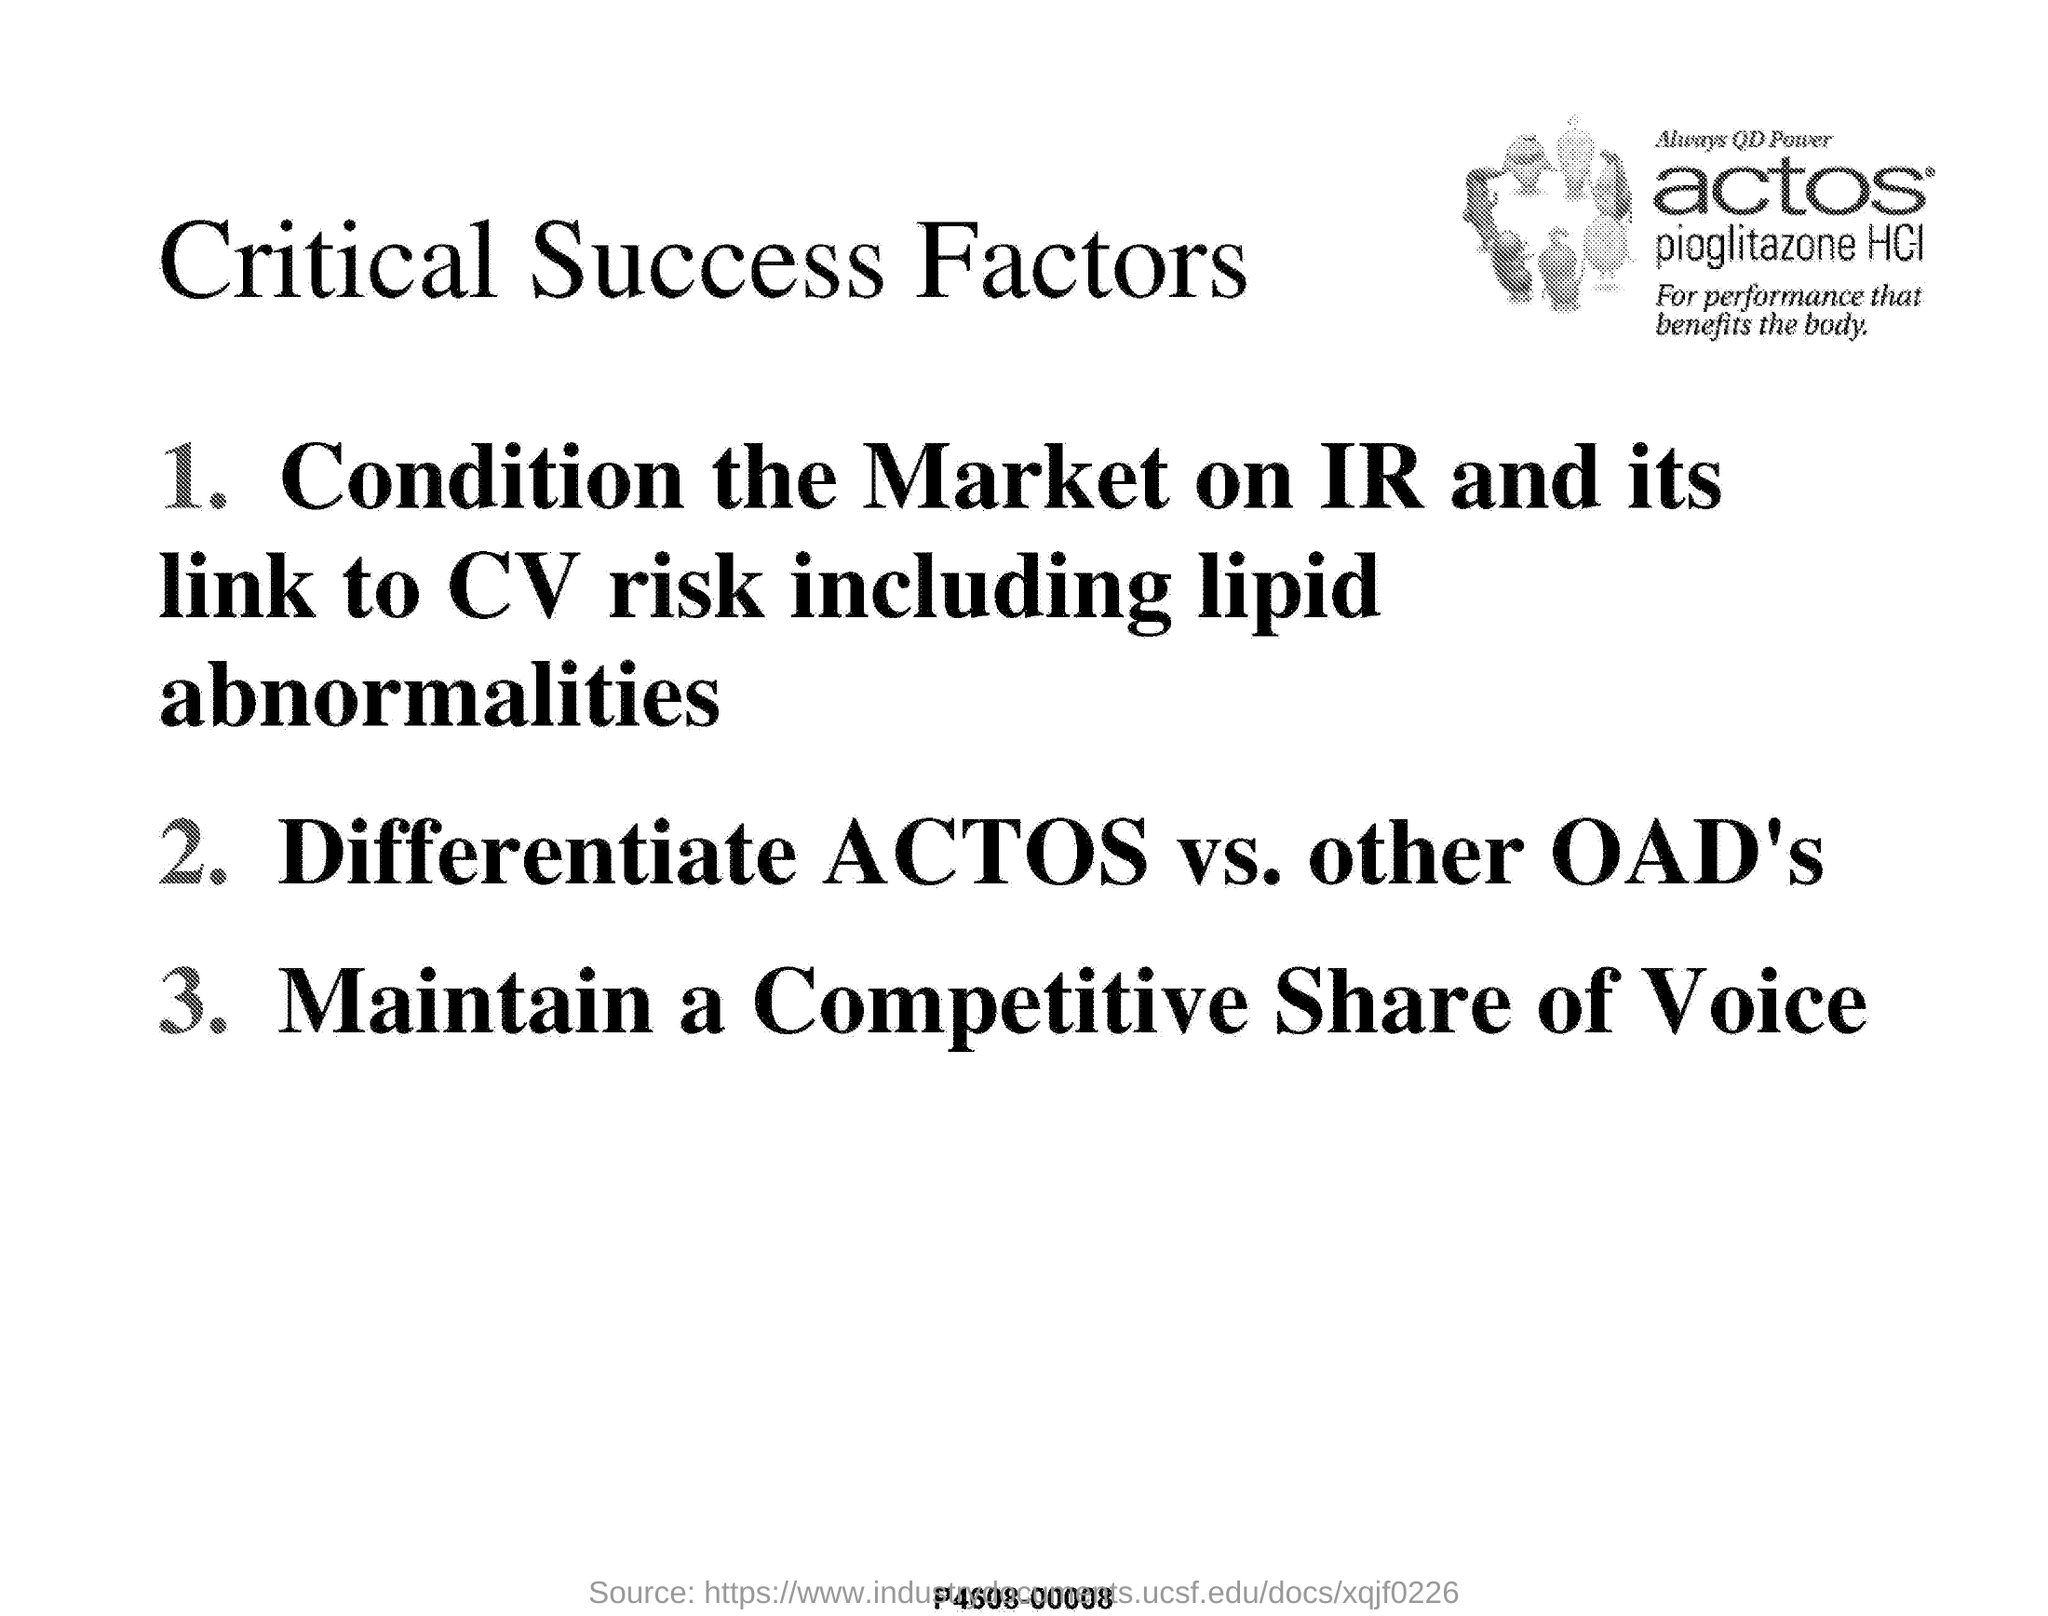What is the title of this document?
Provide a short and direct response. CRITICAL SUCCESS FACTORS. 